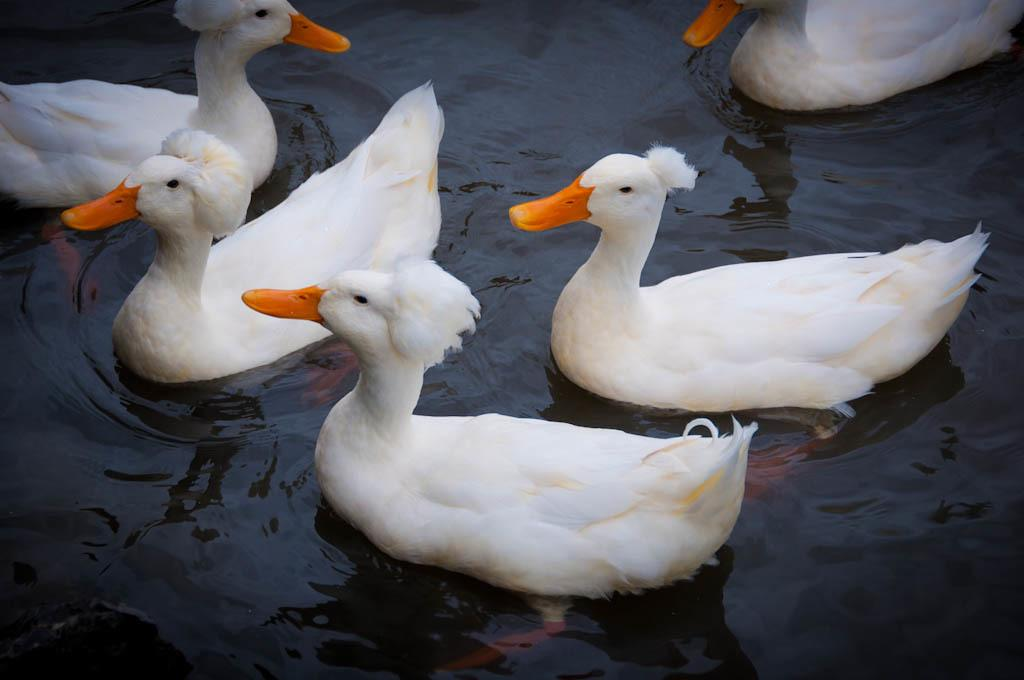What type of animals are in the image? There are ducks in the image. What color are the ducks? The ducks are white in color. Where are the ducks located in the image? The ducks are on the water. What type of system is the duck using to fly in the image? The image does not show the ducks flying, so there is no system to discuss. 